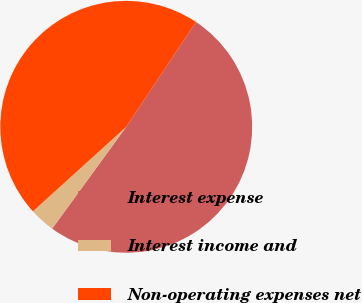<chart> <loc_0><loc_0><loc_500><loc_500><pie_chart><fcel>Interest expense<fcel>Interest income and<fcel>Non-operating expenses net<nl><fcel>50.66%<fcel>3.28%<fcel>46.06%<nl></chart> 